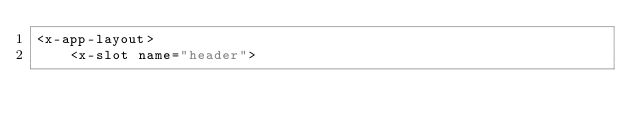Convert code to text. <code><loc_0><loc_0><loc_500><loc_500><_PHP_><x-app-layout>
    <x-slot name="header"></code> 